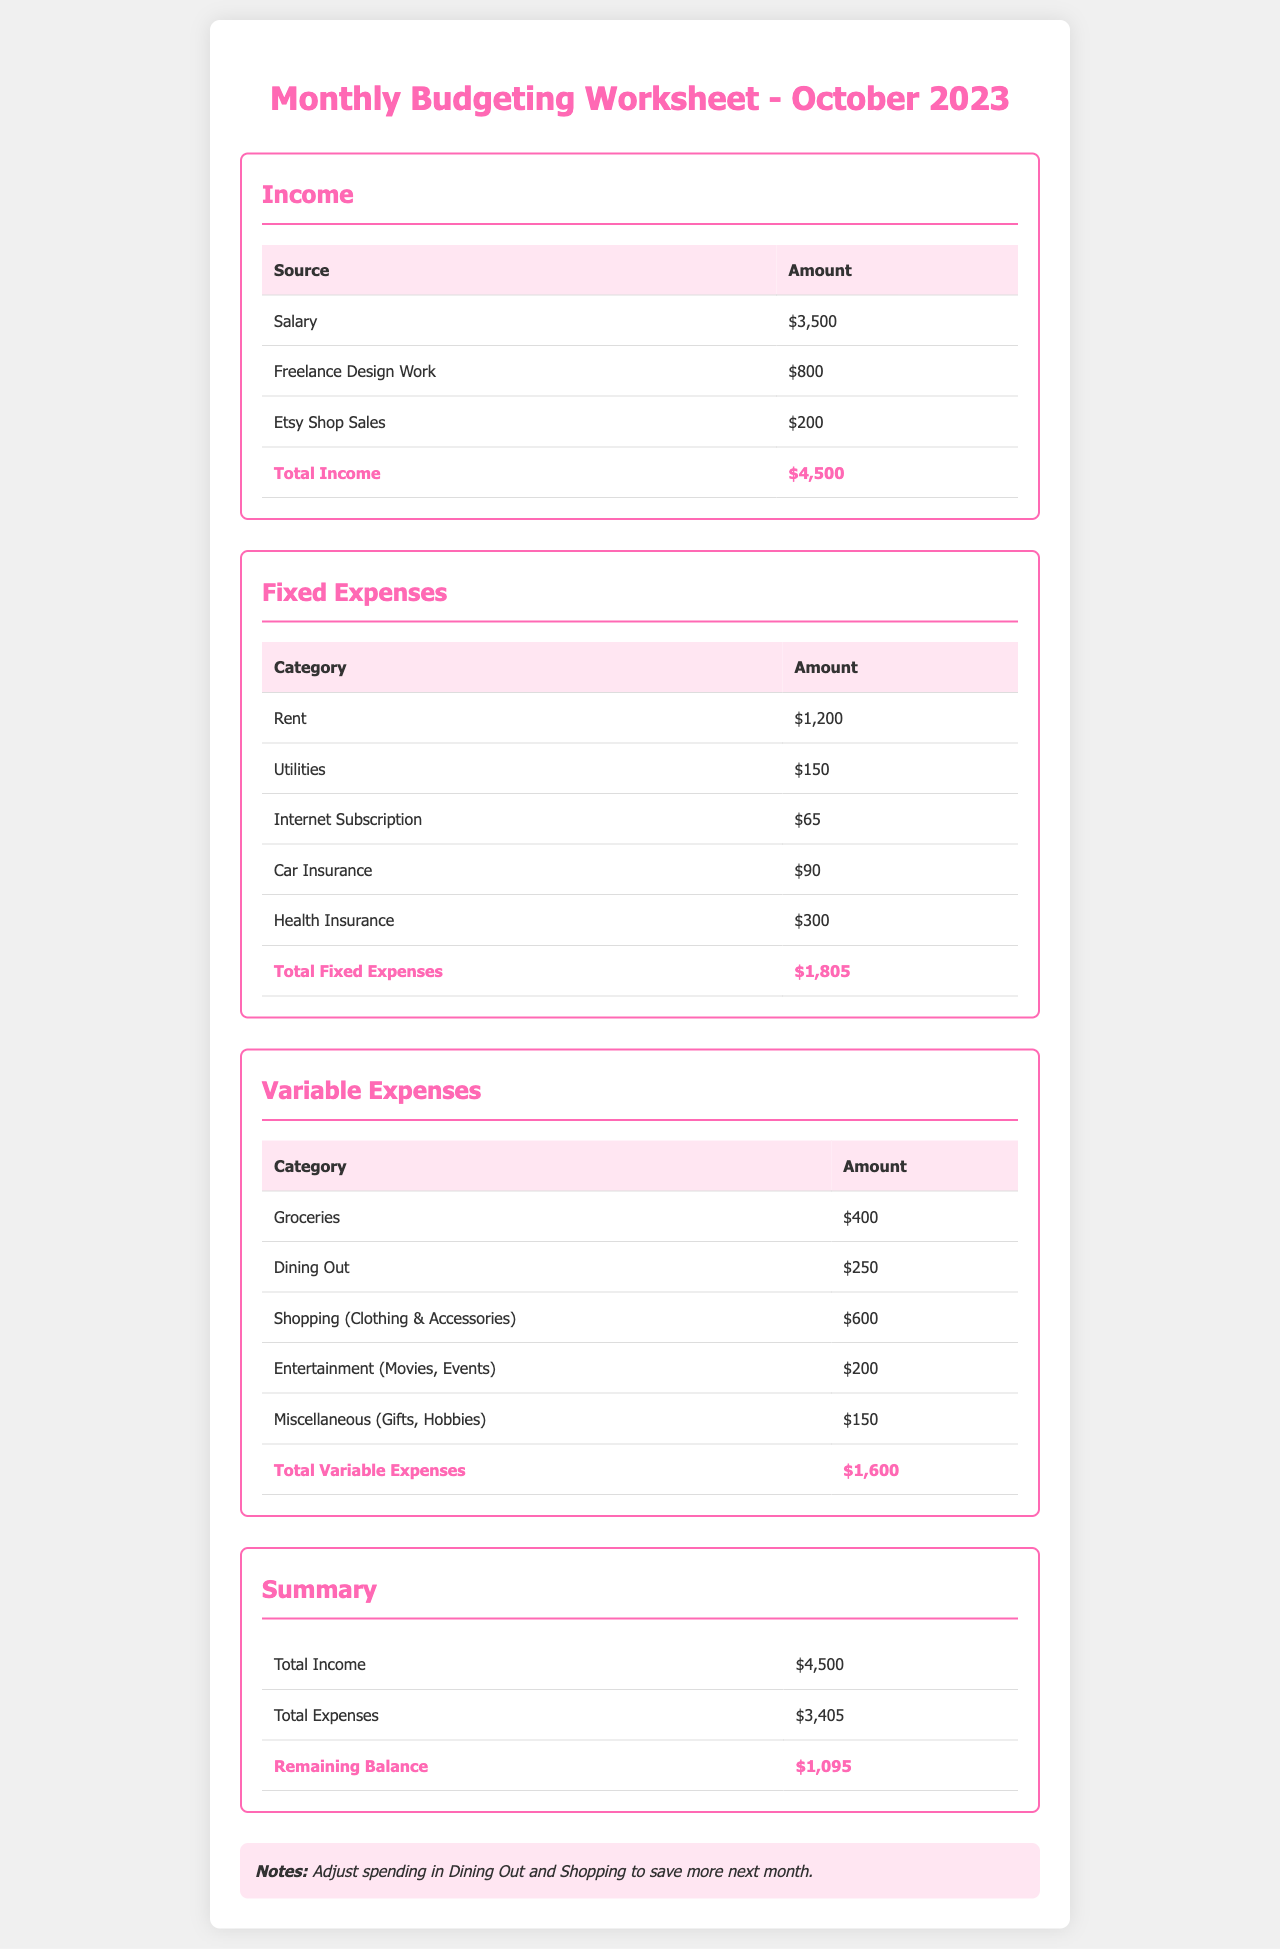What is the total income? The total income is the sum of all income sources listed, which is $3,500 + $800 + $200 = $4,500.
Answer: $4,500 What is the amount for groceries in variable expenses? The document specifies that the amount for groceries is $400.
Answer: $400 What is the largest fixed expense? The largest fixed expense is rent, which is listed as $1,200.
Answer: $1,200 What is the total amount spent on shopping (clothing & accessories)? The document states that the total amount spent on shopping is $600.
Answer: $600 What is the remaining balance after expenses? The remaining balance is calculated by subtracting total expenses from total income, resulting in $4,500 - $3,405 = $1,095.
Answer: $1,095 What is the total for variable expenses? The total for variable expenses is the sum of all variable expense categories, specifically $400 + $250 + $600 + $200 + $150 = $1,600.
Answer: $1,600 How much is allocated for dining out? The document shows that the amount allocated for dining out is $250.
Answer: $250 What type of document is this? This document is a monthly budgeting worksheet designed to track income and expenses.
Answer: Monthly budgeting worksheet Which expense category has the highest amount in fixed expenses? The highest amount in fixed expenses is for health insurance, totaling $300.
Answer: Health insurance 